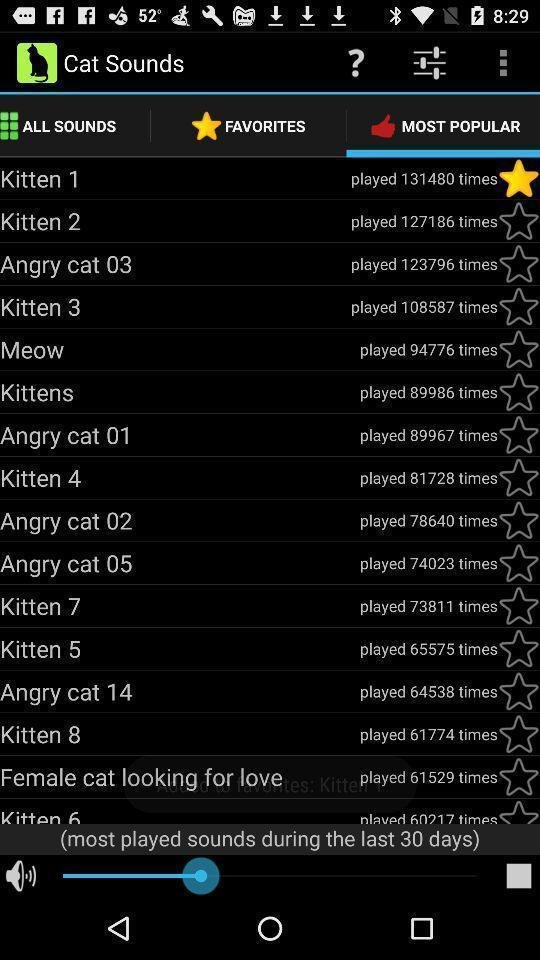What details can you identify in this image? Page showing the most popular cat sounds. 